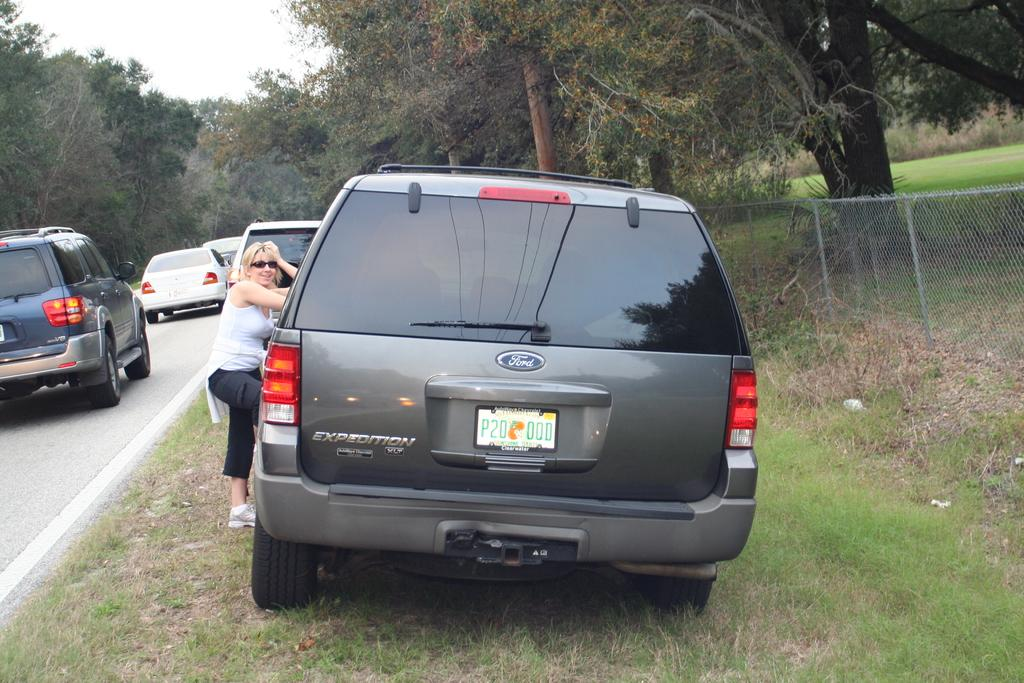Provide a one-sentence caption for the provided image. The grey Ford pulled onto the rass alongside the road is from Clearwater. 